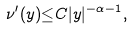Convert formula to latex. <formula><loc_0><loc_0><loc_500><loc_500>\nu ^ { \prime } ( y ) { \leq } C | y | ^ { - \alpha - 1 } ,</formula> 